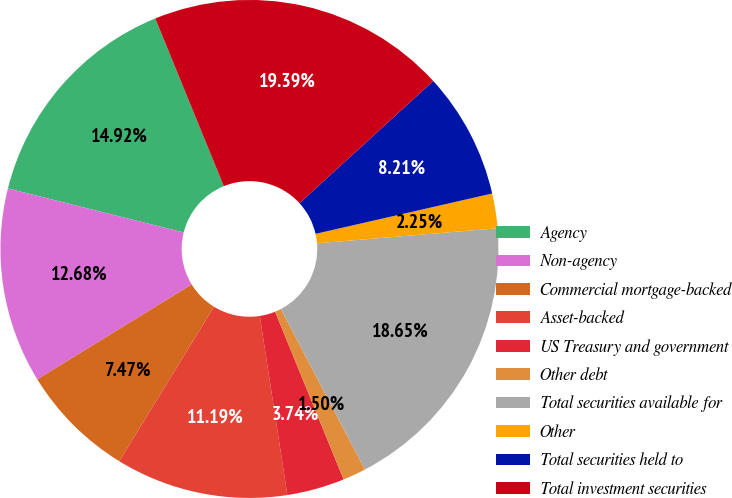Convert chart. <chart><loc_0><loc_0><loc_500><loc_500><pie_chart><fcel>Agency<fcel>Non-agency<fcel>Commercial mortgage-backed<fcel>Asset-backed<fcel>US Treasury and government<fcel>Other debt<fcel>Total securities available for<fcel>Other<fcel>Total securities held to<fcel>Total investment securities<nl><fcel>14.92%<fcel>12.68%<fcel>7.47%<fcel>11.19%<fcel>3.74%<fcel>1.5%<fcel>18.65%<fcel>2.25%<fcel>8.21%<fcel>19.39%<nl></chart> 